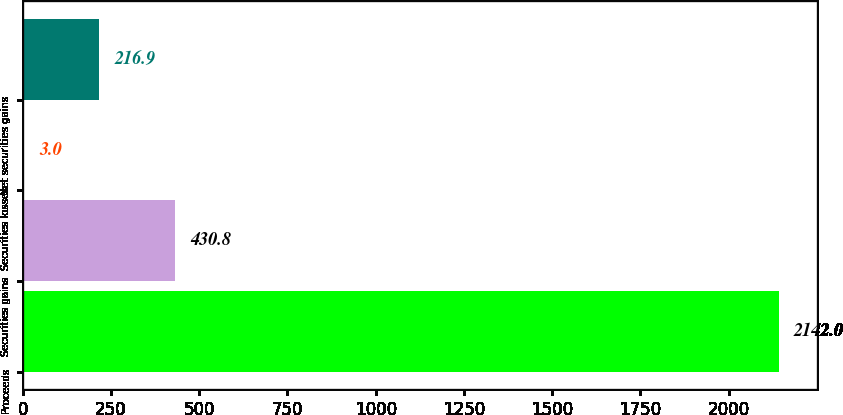Convert chart. <chart><loc_0><loc_0><loc_500><loc_500><bar_chart><fcel>Proceeds<fcel>Securities gains<fcel>Securities losses<fcel>Net securities gains<nl><fcel>2142<fcel>430.8<fcel>3<fcel>216.9<nl></chart> 